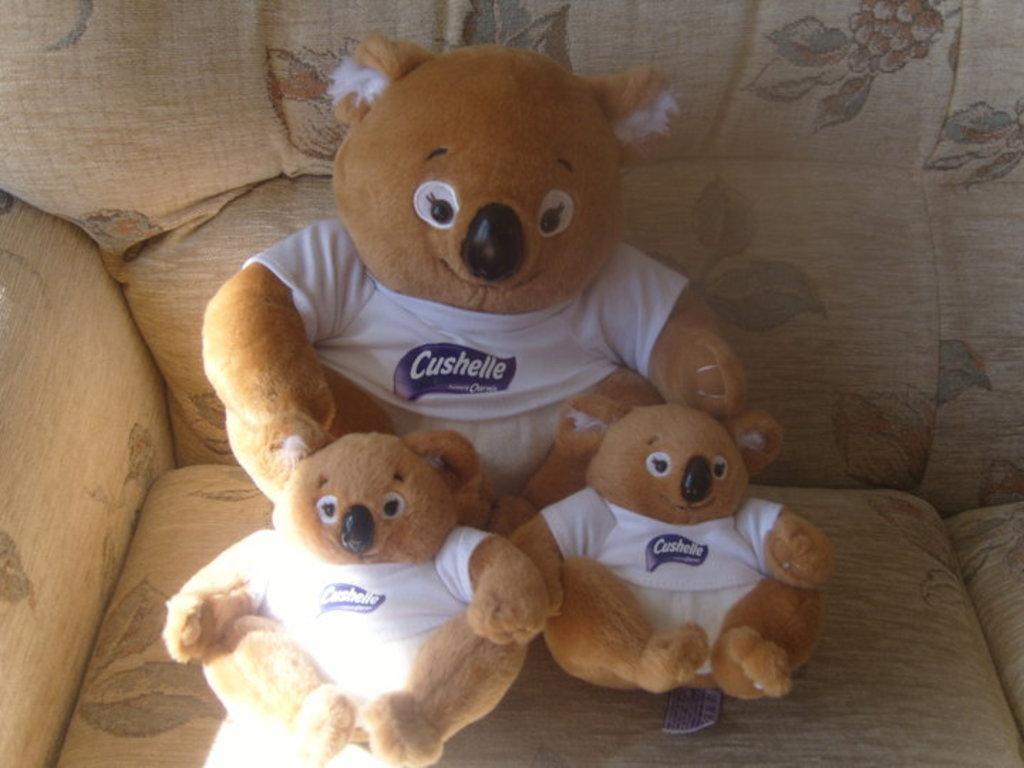Describe this image in one or two sentences. In this image, we can see some teddy bears on the sofa. 